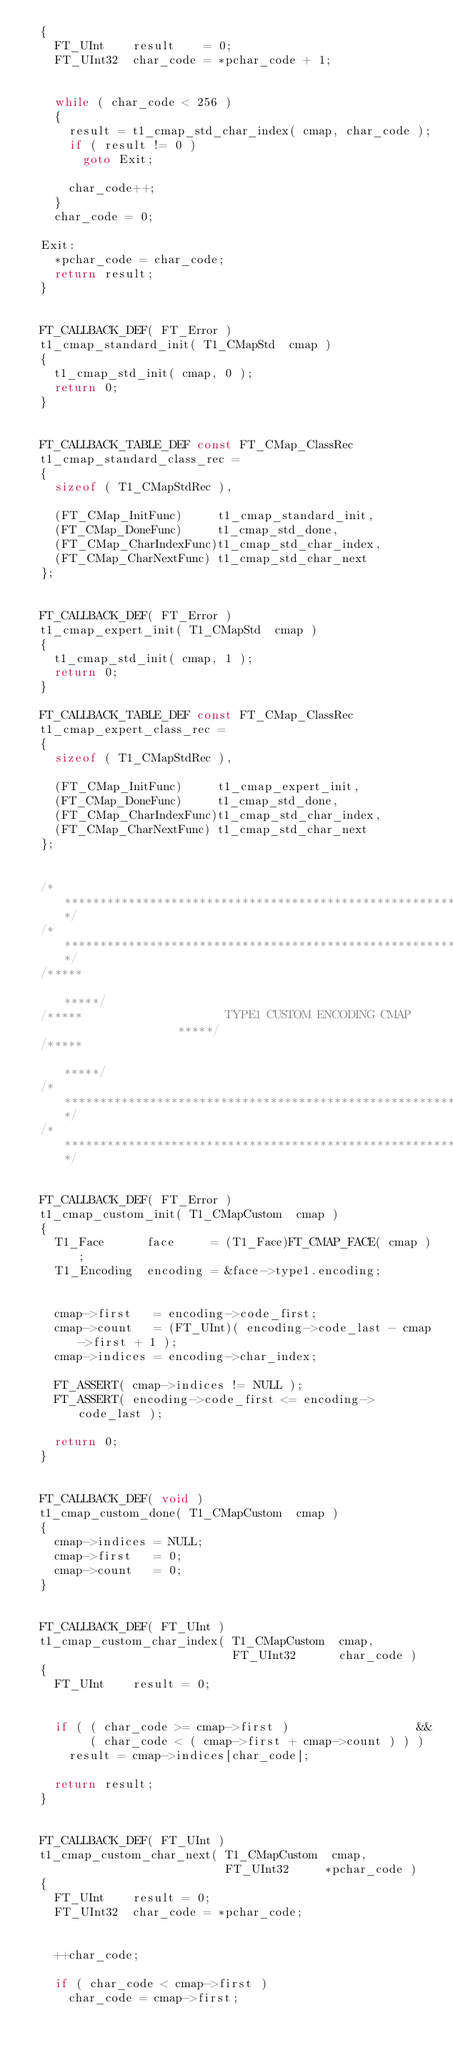Convert code to text. <code><loc_0><loc_0><loc_500><loc_500><_C_>  {
    FT_UInt    result    = 0;
    FT_UInt32  char_code = *pchar_code + 1;


    while ( char_code < 256 )
    {
      result = t1_cmap_std_char_index( cmap, char_code );
      if ( result != 0 )
        goto Exit;

      char_code++;
    }
    char_code = 0;

  Exit:
    *pchar_code = char_code;
    return result;
  }


  FT_CALLBACK_DEF( FT_Error )
  t1_cmap_standard_init( T1_CMapStd  cmap )
  {
    t1_cmap_std_init( cmap, 0 );
    return 0;
  }


  FT_CALLBACK_TABLE_DEF const FT_CMap_ClassRec
  t1_cmap_standard_class_rec =
  {
    sizeof ( T1_CMapStdRec ),

    (FT_CMap_InitFunc)     t1_cmap_standard_init,
    (FT_CMap_DoneFunc)     t1_cmap_std_done,
    (FT_CMap_CharIndexFunc)t1_cmap_std_char_index,
    (FT_CMap_CharNextFunc) t1_cmap_std_char_next
  };


  FT_CALLBACK_DEF( FT_Error )
  t1_cmap_expert_init( T1_CMapStd  cmap )
  {
    t1_cmap_std_init( cmap, 1 );
    return 0;
  }

  FT_CALLBACK_TABLE_DEF const FT_CMap_ClassRec
  t1_cmap_expert_class_rec =
  {
    sizeof ( T1_CMapStdRec ),

    (FT_CMap_InitFunc)     t1_cmap_expert_init,
    (FT_CMap_DoneFunc)     t1_cmap_std_done,
    (FT_CMap_CharIndexFunc)t1_cmap_std_char_index,
    (FT_CMap_CharNextFunc) t1_cmap_std_char_next
  };


  /*************************************************************************/
  /*************************************************************************/
  /*****                                                               *****/
  /*****                    TYPE1 CUSTOM ENCODING CMAP                 *****/
  /*****                                                               *****/
  /*************************************************************************/
  /*************************************************************************/


  FT_CALLBACK_DEF( FT_Error )
  t1_cmap_custom_init( T1_CMapCustom  cmap )
  {
    T1_Face      face     = (T1_Face)FT_CMAP_FACE( cmap );
    T1_Encoding  encoding = &face->type1.encoding;


    cmap->first   = encoding->code_first;
    cmap->count   = (FT_UInt)( encoding->code_last - cmap->first + 1 );
    cmap->indices = encoding->char_index;

    FT_ASSERT( cmap->indices != NULL );
    FT_ASSERT( encoding->code_first <= encoding->code_last );

    return 0;
  }


  FT_CALLBACK_DEF( void )
  t1_cmap_custom_done( T1_CMapCustom  cmap )
  {
    cmap->indices = NULL;
    cmap->first   = 0;
    cmap->count   = 0;
  }


  FT_CALLBACK_DEF( FT_UInt )
  t1_cmap_custom_char_index( T1_CMapCustom  cmap,
                             FT_UInt32      char_code )
  {
    FT_UInt    result = 0;


    if ( ( char_code >= cmap->first )                  &&
         ( char_code < ( cmap->first + cmap->count ) ) )
      result = cmap->indices[char_code];

    return result;
  }


  FT_CALLBACK_DEF( FT_UInt )
  t1_cmap_custom_char_next( T1_CMapCustom  cmap,
                            FT_UInt32     *pchar_code )
  {
    FT_UInt    result = 0;
    FT_UInt32  char_code = *pchar_code;


    ++char_code;

    if ( char_code < cmap->first )
      char_code = cmap->first;
</code> 